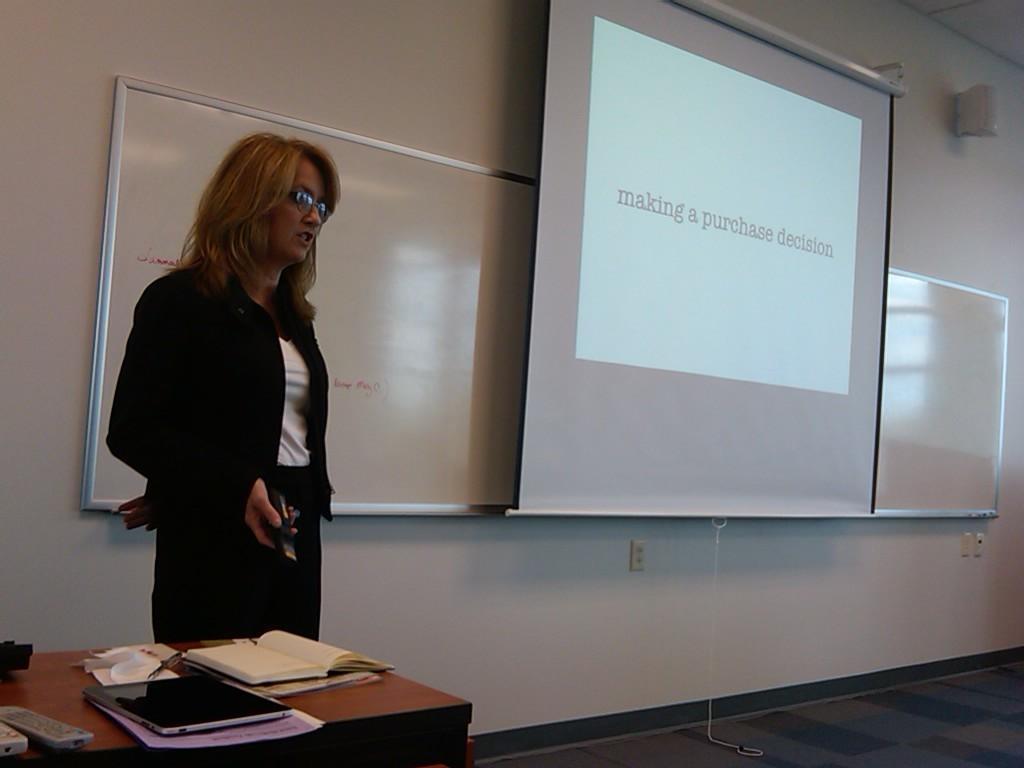Could you give a brief overview of what you see in this image? In this picture there is a woman standing and holding a remote in her hand. There is a screen. There is a book, laptop and paper on the table. 